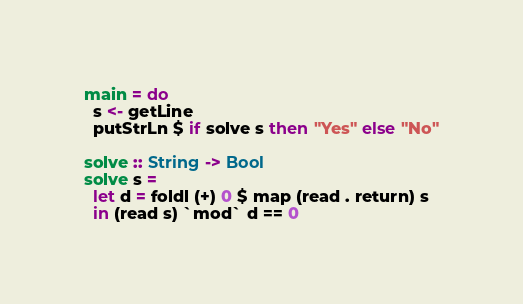<code> <loc_0><loc_0><loc_500><loc_500><_Haskell_>main = do
  s <- getLine
  putStrLn $ if solve s then "Yes" else "No"
 
solve :: String -> Bool
solve s = 
  let d = foldl (+) 0 $ map (read . return) s
  in (read s) `mod` d == 0</code> 